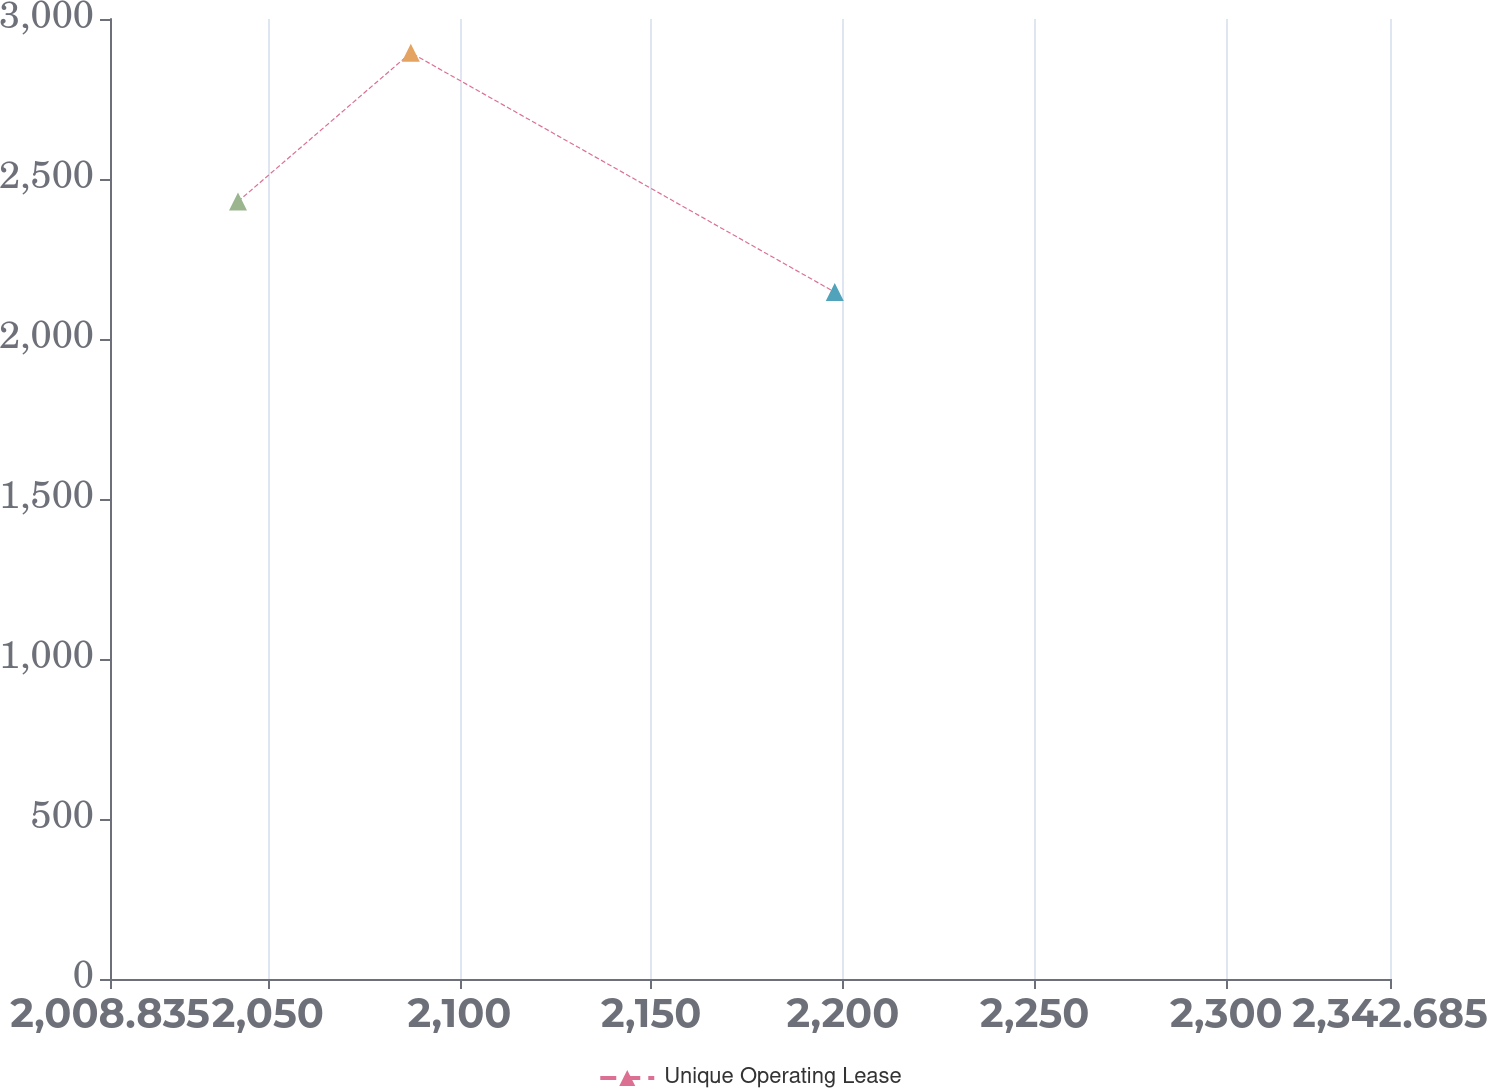<chart> <loc_0><loc_0><loc_500><loc_500><line_chart><ecel><fcel>Unique Operating Lease<nl><fcel>2042.22<fcel>2429.75<nl><fcel>2087.29<fcel>2894.49<nl><fcel>2197.86<fcel>2146.53<nl><fcel>2344.99<fcel>3302.77<nl><fcel>2376.07<fcel>2778.87<nl></chart> 